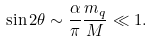<formula> <loc_0><loc_0><loc_500><loc_500>\sin { 2 \theta } \sim \frac { \alpha } { \pi } \frac { m _ { q } } { M } \ll 1 .</formula> 